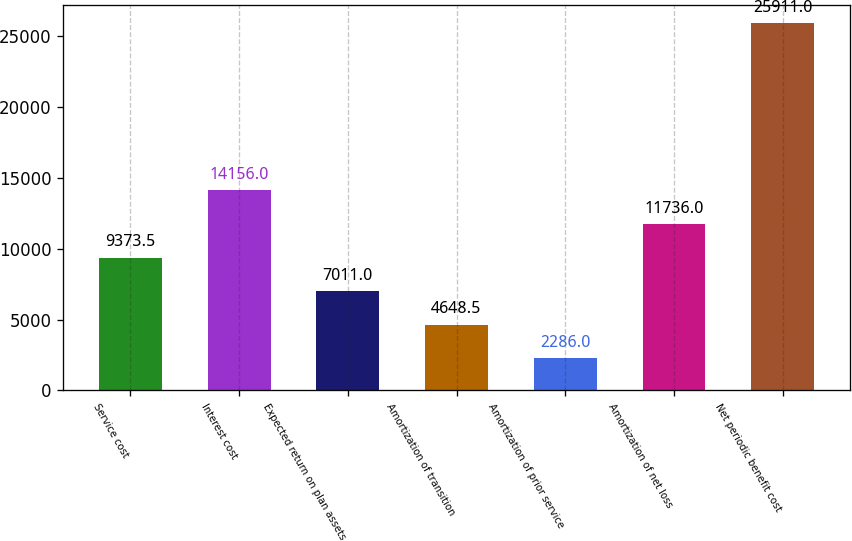Convert chart. <chart><loc_0><loc_0><loc_500><loc_500><bar_chart><fcel>Service cost<fcel>Interest cost<fcel>Expected return on plan assets<fcel>Amortization of transition<fcel>Amortization of prior service<fcel>Amortization of net loss<fcel>Net periodic benefit cost<nl><fcel>9373.5<fcel>14156<fcel>7011<fcel>4648.5<fcel>2286<fcel>11736<fcel>25911<nl></chart> 